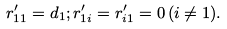<formula> <loc_0><loc_0><loc_500><loc_500>r ^ { \prime } _ { 1 1 } = d _ { 1 } ; r ^ { \prime } _ { 1 i } = r ^ { \prime } _ { i 1 } = 0 \, ( i \ne 1 ) .</formula> 